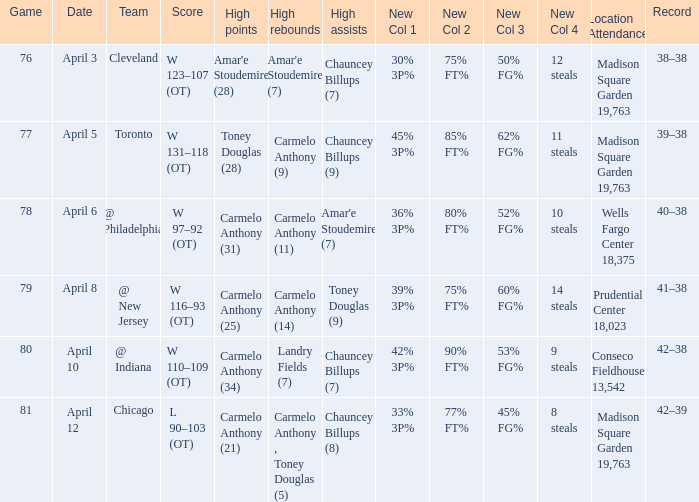Name the date for cleveland April 3. 